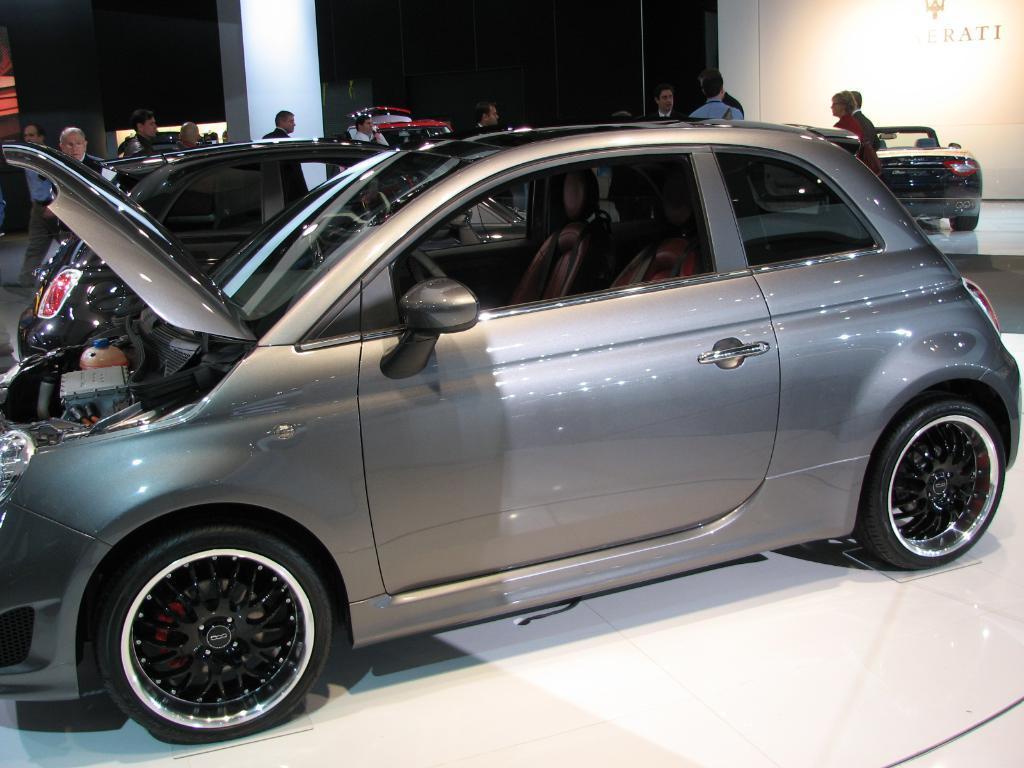How would you summarize this image in a sentence or two? In this image we can see motor vehicles and persons on the floor. 